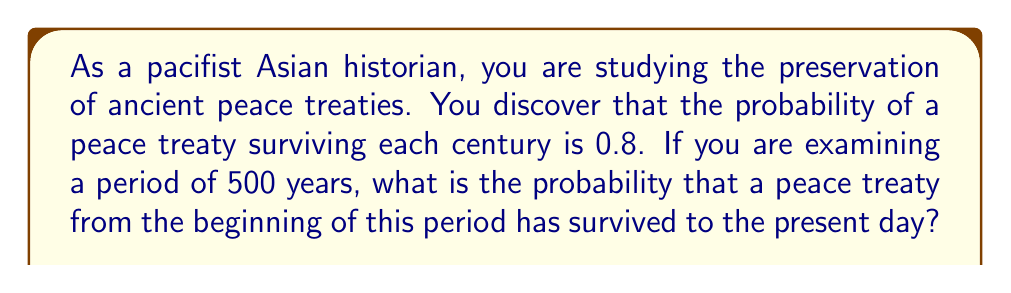What is the answer to this math problem? To solve this problem, we need to consider the following:

1. The probability of survival for each century is 0.8.
2. We are looking at a period of 500 years, which is 5 centuries.
3. For the peace treaty to survive the entire 500-year period, it must survive each of the 5 centuries.

This scenario follows the multiplication rule of probability, where we multiply the probabilities of independent events occurring together.

Let's define the probability of survival for the entire period as $P(survival)$.

$$P(survival) = (0.8)^5$$

This is because:
- The treaty needs to survive 5 consecutive centuries
- Each century has a survival probability of 0.8
- These events are independent of each other

Now, let's calculate:

$$\begin{align}
P(survival) &= (0.8)^5 \\
&= 0.8 \times 0.8 \times 0.8 \times 0.8 \times 0.8 \\
&= 0.32768
\end{align}$$

Therefore, the probability that a peace treaty from the beginning of the 500-year period has survived to the present day is approximately 0.32768 or about 32.77%.
Answer: 0.32768 or approximately 32.77% 